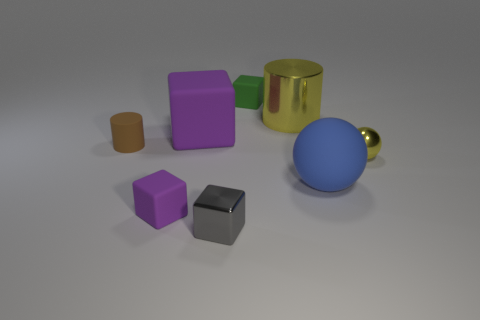Add 1 large purple rubber things. How many objects exist? 9 Subtract all cylinders. How many objects are left? 6 Add 6 tiny green objects. How many tiny green objects are left? 7 Add 2 blue matte balls. How many blue matte balls exist? 3 Subtract 0 brown spheres. How many objects are left? 8 Subtract all large yellow cylinders. Subtract all purple cubes. How many objects are left? 5 